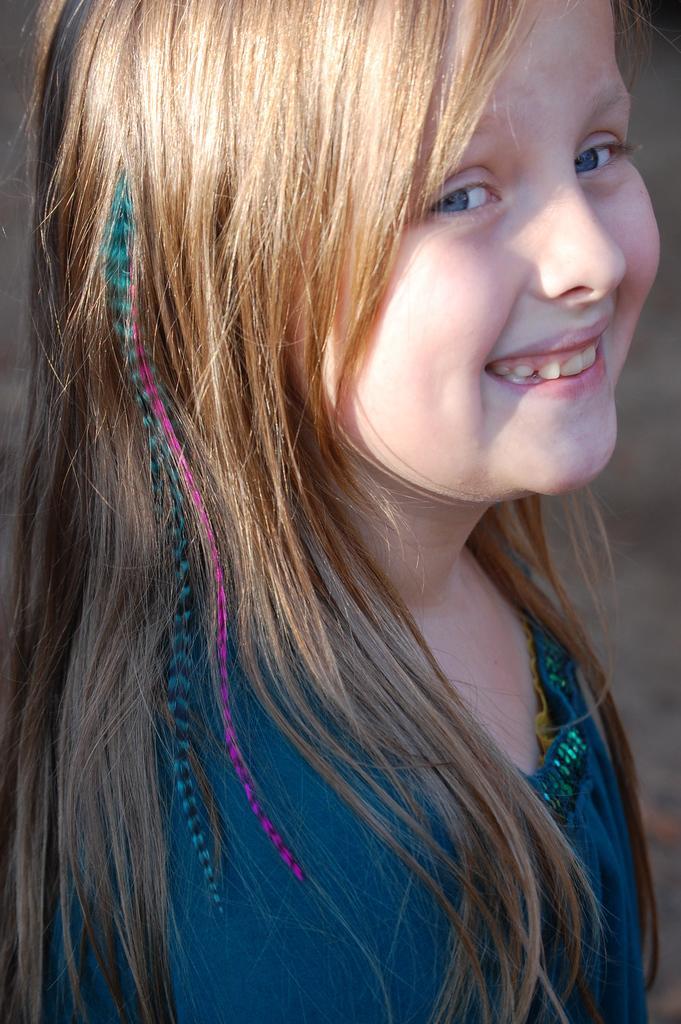In one or two sentences, can you explain what this image depicts? In this image there is a girl. 